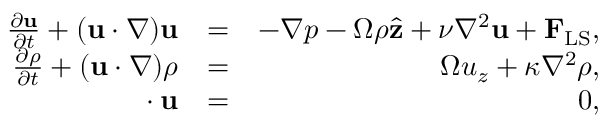Convert formula to latex. <formula><loc_0><loc_0><loc_500><loc_500>\begin{array} { r l r } { \frac { \partial { u } } { \partial { t } } + ( u \cdot \nabla ) u } & { = } & { - \nabla p - \Omega \rho \hat { z } + \nu \nabla ^ { 2 } u + { F } _ { L S } , } \\ { \frac { \partial { \rho } } { \partial { t } } + ( u \cdot \nabla ) \rho } & { = } & { \Omega u _ { z } + \kappa \nabla ^ { 2 } \rho , } \\ { \nabla \cdot u } & { = } & { 0 , } \end{array}</formula> 